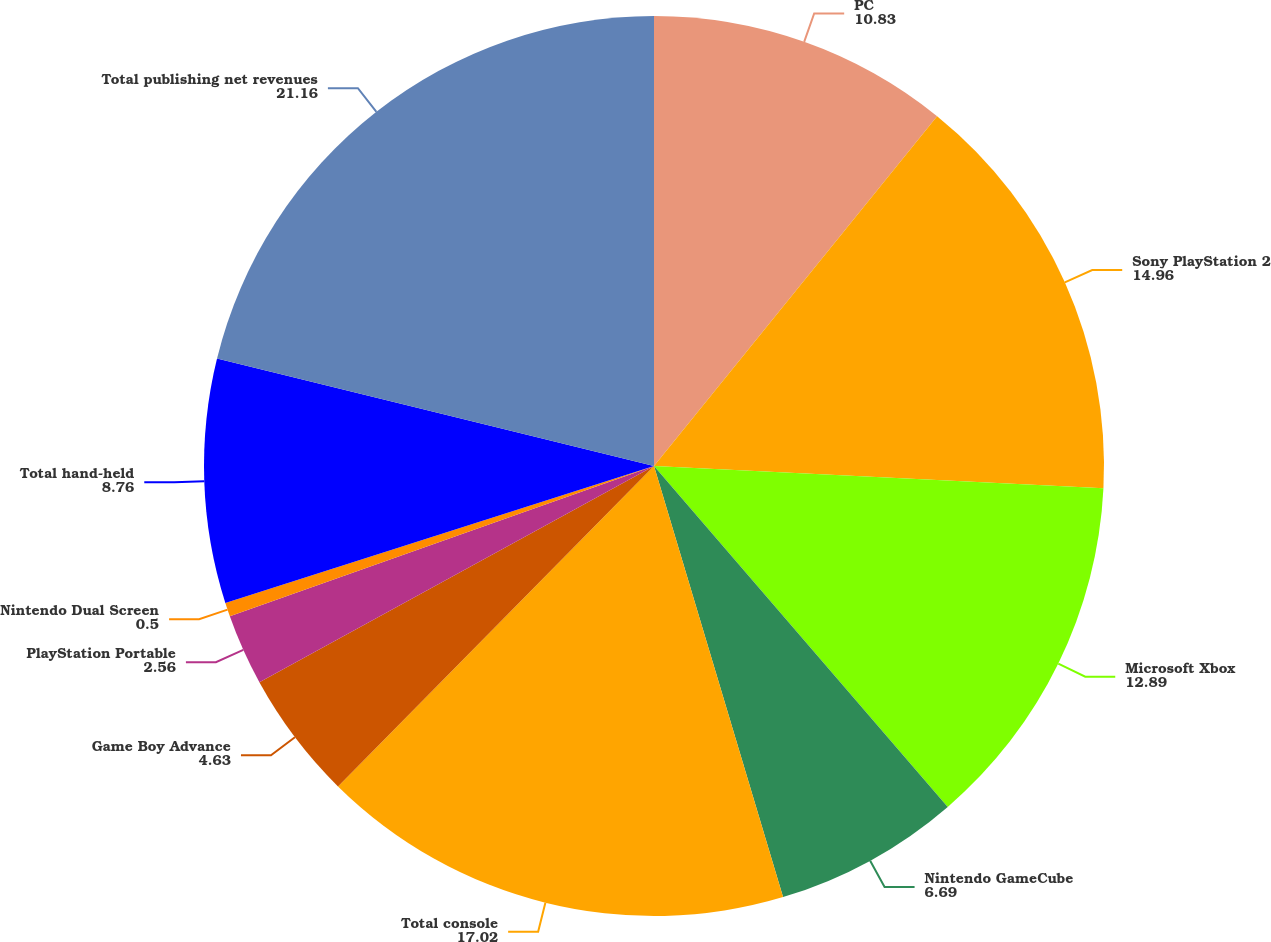Convert chart. <chart><loc_0><loc_0><loc_500><loc_500><pie_chart><fcel>PC<fcel>Sony PlayStation 2<fcel>Microsoft Xbox<fcel>Nintendo GameCube<fcel>Total console<fcel>Game Boy Advance<fcel>PlayStation Portable<fcel>Nintendo Dual Screen<fcel>Total hand-held<fcel>Total publishing net revenues<nl><fcel>10.83%<fcel>14.96%<fcel>12.89%<fcel>6.69%<fcel>17.02%<fcel>4.63%<fcel>2.56%<fcel>0.5%<fcel>8.76%<fcel>21.16%<nl></chart> 